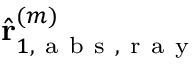<formula> <loc_0><loc_0><loc_500><loc_500>\hat { r } _ { 1 , a b s , r a y } ^ { ( m ) }</formula> 